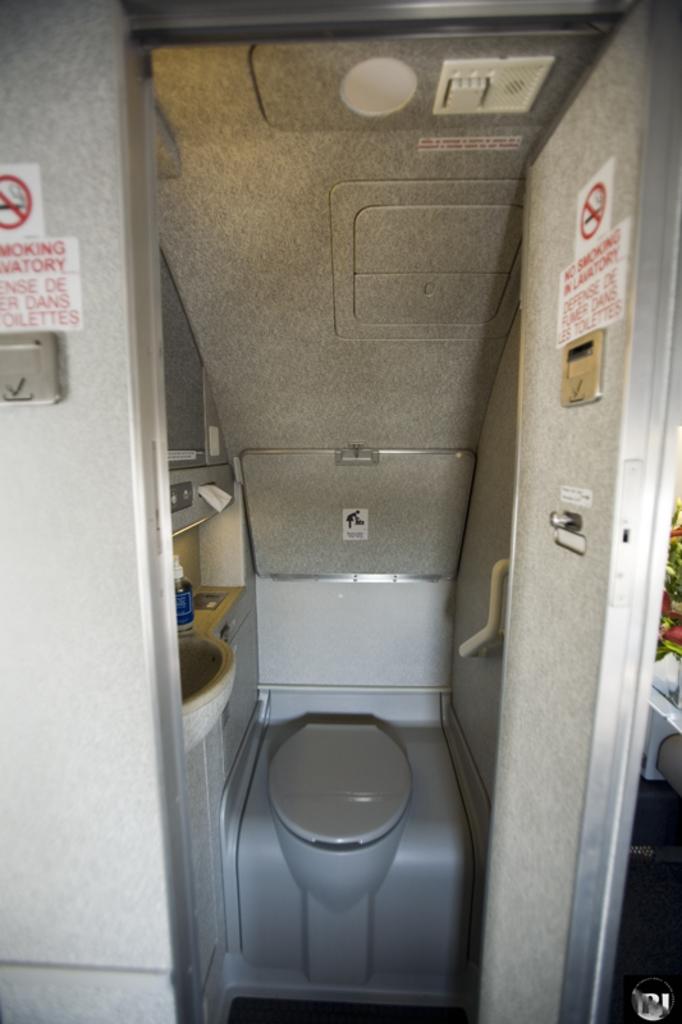What it is?
Offer a very short reply. Answering does not require reading text in the image. This is toilet?
Give a very brief answer. Yes. 